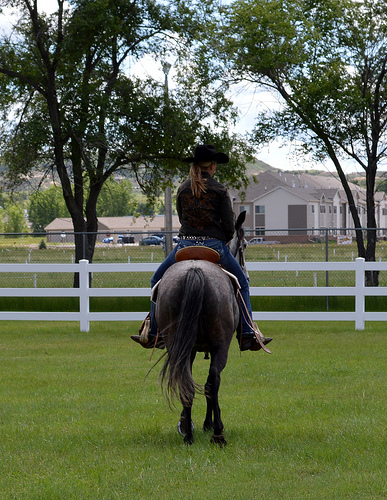<image>
Can you confirm if the lady is next to the horse? No. The lady is not positioned next to the horse. They are located in different areas of the scene. 